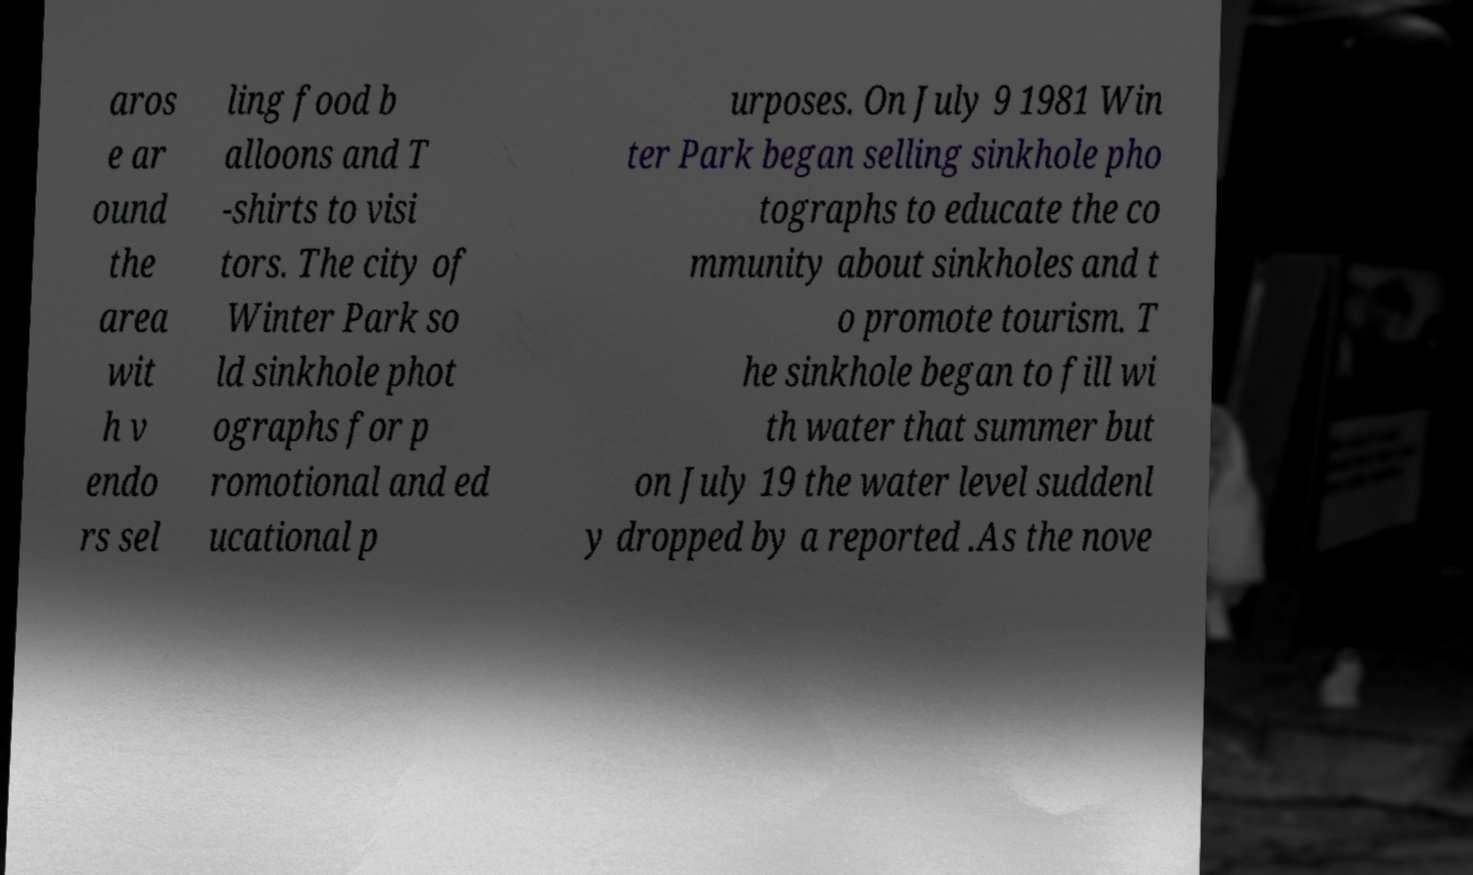For documentation purposes, I need the text within this image transcribed. Could you provide that? aros e ar ound the area wit h v endo rs sel ling food b alloons and T -shirts to visi tors. The city of Winter Park so ld sinkhole phot ographs for p romotional and ed ucational p urposes. On July 9 1981 Win ter Park began selling sinkhole pho tographs to educate the co mmunity about sinkholes and t o promote tourism. T he sinkhole began to fill wi th water that summer but on July 19 the water level suddenl y dropped by a reported .As the nove 